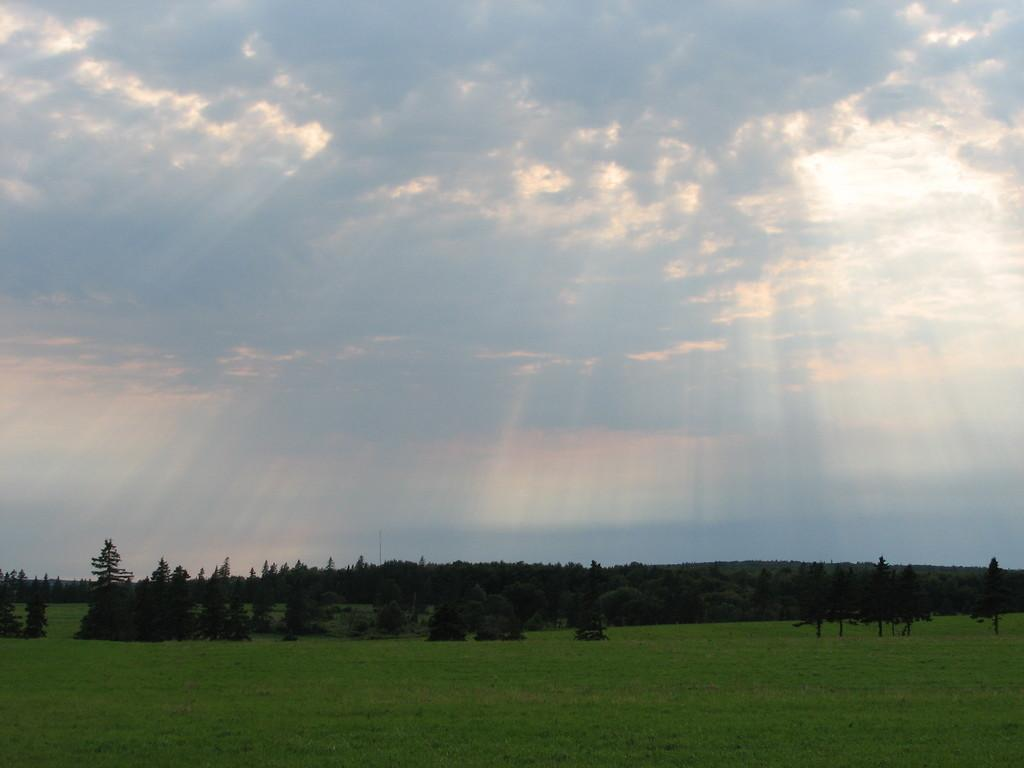What type of vegetation can be seen in the image? There is grass and trees in the image. What else is visible in the image besides vegetation? The sky is visible in the image. How would you describe the weather based on the appearance of the sky? The sky appears to be sunny in the image. What type of toys can be seen in the image? There are no toys present in the image. Is there any writing visible on the grass in the image? There is no writing visible on the grass or any other part of the image. 